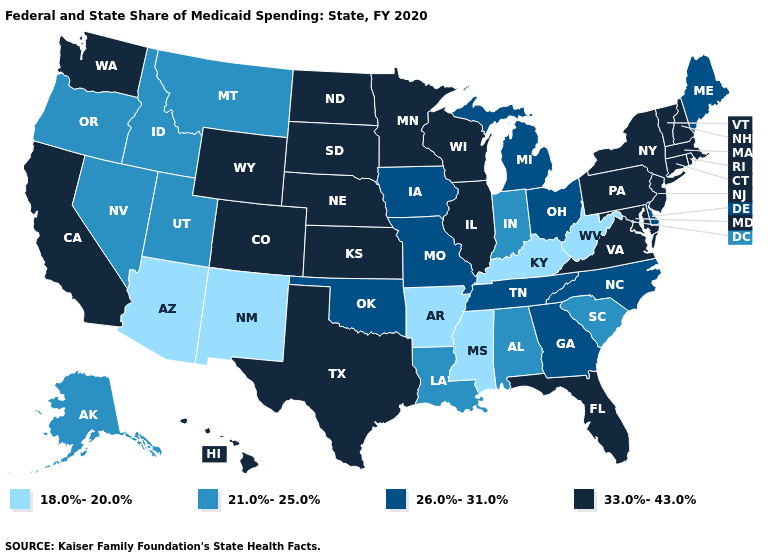Does Iowa have the highest value in the MidWest?
Concise answer only. No. What is the lowest value in states that border New York?
Concise answer only. 33.0%-43.0%. Does New York have the highest value in the Northeast?
Keep it brief. Yes. How many symbols are there in the legend?
Concise answer only. 4. Does the map have missing data?
Answer briefly. No. Does Minnesota have the highest value in the USA?
Write a very short answer. Yes. What is the value of New Mexico?
Be succinct. 18.0%-20.0%. What is the value of Iowa?
Short answer required. 26.0%-31.0%. Does New Hampshire have the same value as Nebraska?
Keep it brief. Yes. What is the highest value in states that border Pennsylvania?
Be succinct. 33.0%-43.0%. What is the highest value in the USA?
Concise answer only. 33.0%-43.0%. What is the highest value in states that border Wyoming?
Be succinct. 33.0%-43.0%. Name the states that have a value in the range 21.0%-25.0%?
Answer briefly. Alabama, Alaska, Idaho, Indiana, Louisiana, Montana, Nevada, Oregon, South Carolina, Utah. Name the states that have a value in the range 18.0%-20.0%?
Keep it brief. Arizona, Arkansas, Kentucky, Mississippi, New Mexico, West Virginia. How many symbols are there in the legend?
Answer briefly. 4. 